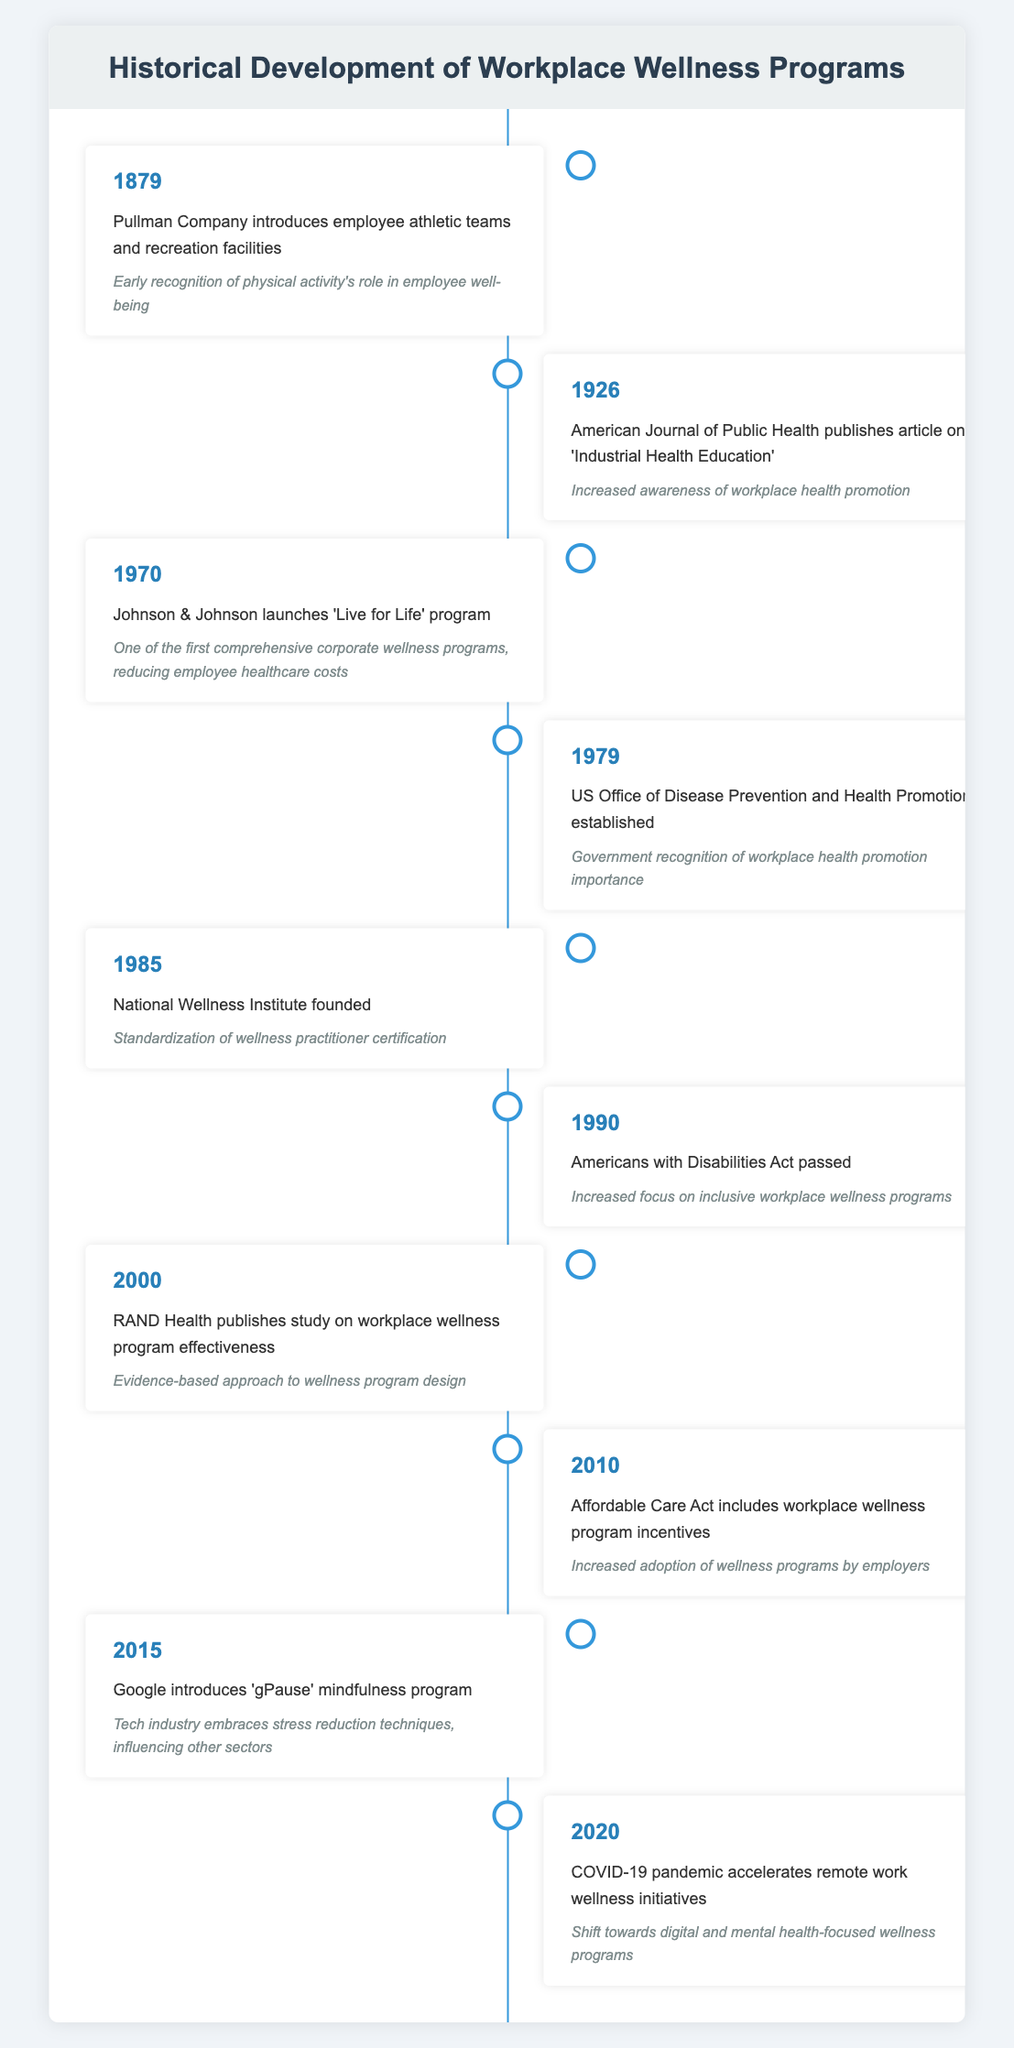What year did the Pullman Company introduce employee athletic teams? The table shows that the event occurred in 1879. This is a specific retrieval question that looks for a fact directly stated in the timeline.
Answer: 1879 What was the impact of the RAND Health study published in 2000? The impact states that it provided an evidence-based approach to wellness program design. This is another retrieval question based on information in a single row.
Answer: Evidence-based approach to wellness program design How many significant events related to workplace wellness occurred before 1980? By looking at the years listed before 1980 (1879, 1926, 1970, 1979), there are four significant events. This requires counting the entries in the table that are prior to 1980.
Answer: 4 Did the Affordable Care Act include workplace wellness program incentives? The table indicates that it did in 2010. This is a fact-based question that can be answered by confirming information in a single row.
Answer: Yes What was the trend in workplace wellness programs from 1970 to 2020? From the timeline, we can see that workplace wellness programs evolved from physical activities and early initiatives in the 1970s to more structured, government-supported programs in the 1980s, and then transitioned towards inclusive and digital programs by 2020, especially due to the effects of the COVID-19 pandemic. This question requires synthesizing information over multiple events to identify a trend.
Answer: A shift from physical fitness initiatives to inclusive and digital wellness programs What is the difference between the years when the National Wellness Institute was founded and when the Americans with Disabilities Act was passed? The National Wellness Institute was founded in 1985 and the Americans with Disabilities Act was passed in 1990. The difference in years is 1990 - 1985 = 5 years. This involves a simple subtraction operation.
Answer: 5 years What was one of the key impacts of the 'gPause' mindfulness program introduced by Google in 2015? The impact mentioned is that it led to the tech industry embracing stress reduction techniques, influencing other sectors. This question retrieves specific information about the event's impact.
Answer: Tech industry embraces stress reduction techniques How many total years are represented in the timeline from the introduction of athletic teams to the COVID-19 pandemic? The timeline starts from 1879 and ends in 2020. To find the total years, subtract 1879 from 2020, which gives us 141 years. This requires calculating the range covered by the events.
Answer: 141 years 